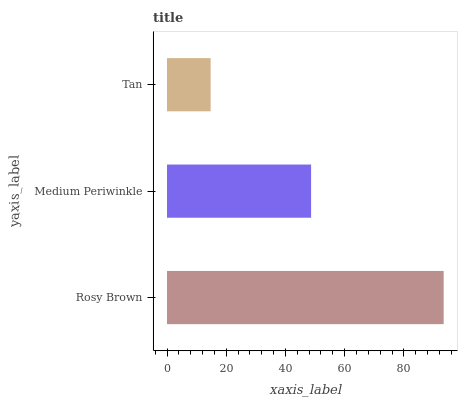Is Tan the minimum?
Answer yes or no. Yes. Is Rosy Brown the maximum?
Answer yes or no. Yes. Is Medium Periwinkle the minimum?
Answer yes or no. No. Is Medium Periwinkle the maximum?
Answer yes or no. No. Is Rosy Brown greater than Medium Periwinkle?
Answer yes or no. Yes. Is Medium Periwinkle less than Rosy Brown?
Answer yes or no. Yes. Is Medium Periwinkle greater than Rosy Brown?
Answer yes or no. No. Is Rosy Brown less than Medium Periwinkle?
Answer yes or no. No. Is Medium Periwinkle the high median?
Answer yes or no. Yes. Is Medium Periwinkle the low median?
Answer yes or no. Yes. Is Tan the high median?
Answer yes or no. No. Is Tan the low median?
Answer yes or no. No. 